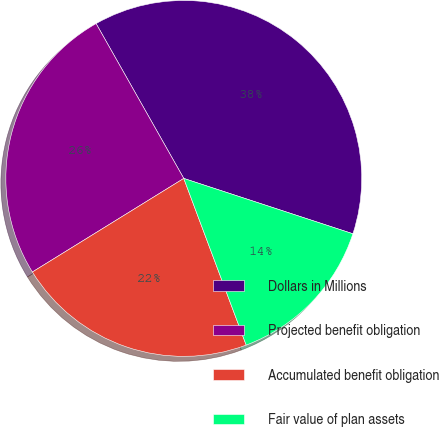Convert chart. <chart><loc_0><loc_0><loc_500><loc_500><pie_chart><fcel>Dollars in Millions<fcel>Projected benefit obligation<fcel>Accumulated benefit obligation<fcel>Fair value of plan assets<nl><fcel>38.23%<fcel>25.61%<fcel>21.89%<fcel>14.26%<nl></chart> 